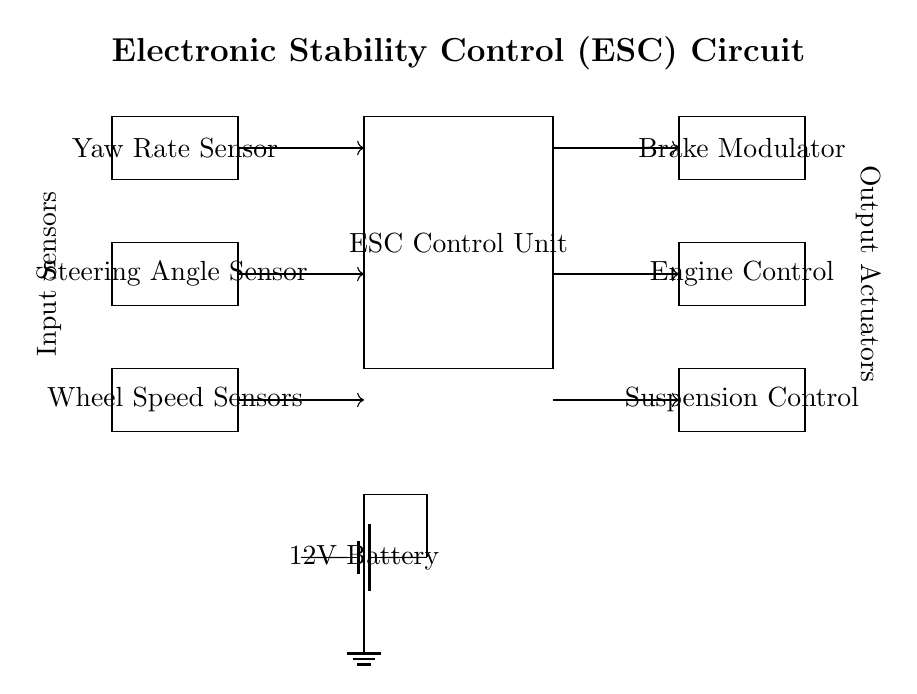What components are included in the circuit? The circuit includes the ESC Control Unit, Yaw Rate Sensor, Steering Angle Sensor, Wheel Speed Sensors, Brake Modulator, Engine Control, and Suspension Control. These components are labeled directly in the diagram.
Answer: ESC Control Unit, Yaw Rate Sensor, Steering Angle Sensor, Wheel Speed Sensors, Brake Modulator, Engine Control, Suspension Control What type of power supply is used in this circuit? The circuit shows a battery labeled as a 12V Battery, which indicates that the power supply for the entire system is a 12 volt battery.
Answer: Battery How many input sensors are present in the circuit? There are three input sensors: Yaw Rate Sensor, Steering Angle Sensor, and Wheel Speed Sensors. The number can be counted directly from the components in the left section of the diagram.
Answer: Three How does the ESC Control Unit connect to the Yaw Rate Sensor? The Yaw Rate Sensor is connected to the ESC Control Unit via a directed arrow indicating a signal flow, which implies that data is sent from the sensor to the control unit for processing.
Answer: A directed arrow Which component controls the braking system? The Brake Modulator is the component that serves to control the braking system, as indicated in the right section of the diagram where it is labeled clearly.
Answer: Brake Modulator What is the function of the Engine Control unit? The Engine Control unit is responsible for adjusting engine parameters based on the input it receives from the ESC Control Unit, contributing to vehicle stability by managing power output. The connection to the ESC Control Unit indicates it uses received data to perform its function.
Answer: Managing engine parameters What is indicated by the connection from the ESC Control Unit to the Suspension Control? The connection indicates that the ESC Control Unit sends signals to the Suspension Control to adjust the vehicle's suspension based on real-time data from the sensors, which helps improve vehicle handling in dangerous situations.
Answer: Signal connection for suspension 